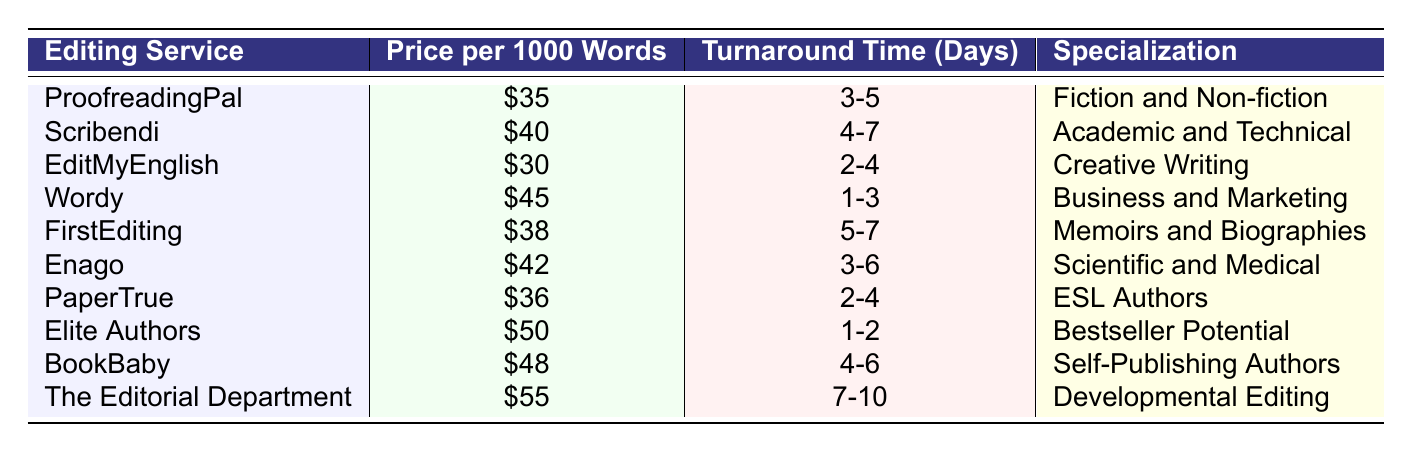What is the price for the ProofreadingPal service? The table shows that the price for the ProofreadingPal service is listed as $35 per 1000 words.
Answer: $35 Which editing service has the shortest turnaround time? Upon reviewing the turnaround times, Wordy has the shortest turnaround time of 1-3 days.
Answer: Wordy What are the specializations provided by EditMyEnglish? The table indicates that EditMyEnglish specializes in Creative Writing.
Answer: Creative Writing How much more expensive is Elite Authors compared to EditMyEnglish? The price for Elite Authors is $50, and for EditMyEnglish it is $30. The difference is $50 - $30 = $20.
Answer: $20 Is the turnaround time for Enago greater than 5 days? Enago's turnaround time is listed as 3-6 days, which means it is not always greater than 5 days since it can also be 3, 4, or 5 days.
Answer: No What is the average price of all editing services listed? To calculate the average, sum all prices: $35 + $40 + $30 + $45 + $38 + $42 + $36 + $50 + $48 + $55. The total is $419. There are 10 services, so the average is $419 / 10 = $41.90.
Answer: $41.90 Which editing service has the highest price, and what is that price? The table indicates that The Editorial Department has the highest price of $55 per 1000 words.
Answer: The Editorial Department, $55 Are all services available for both fiction and non-fiction? Only ProofreadingPal specializes in both Fiction and Non-fiction, while others focus on different areas.
Answer: No How would you categorize services that specialize in Academic and Technical editing? The only service that specializes in Academic and Technical editing is Scribendi as indicated in the table.
Answer: Scribendi What's the range of turnaround times for services targeted at self-publishing authors? BookBaby has a turnaround time of 4-6 days, representing the range specific to self-publishing authors.
Answer: 4-6 days 